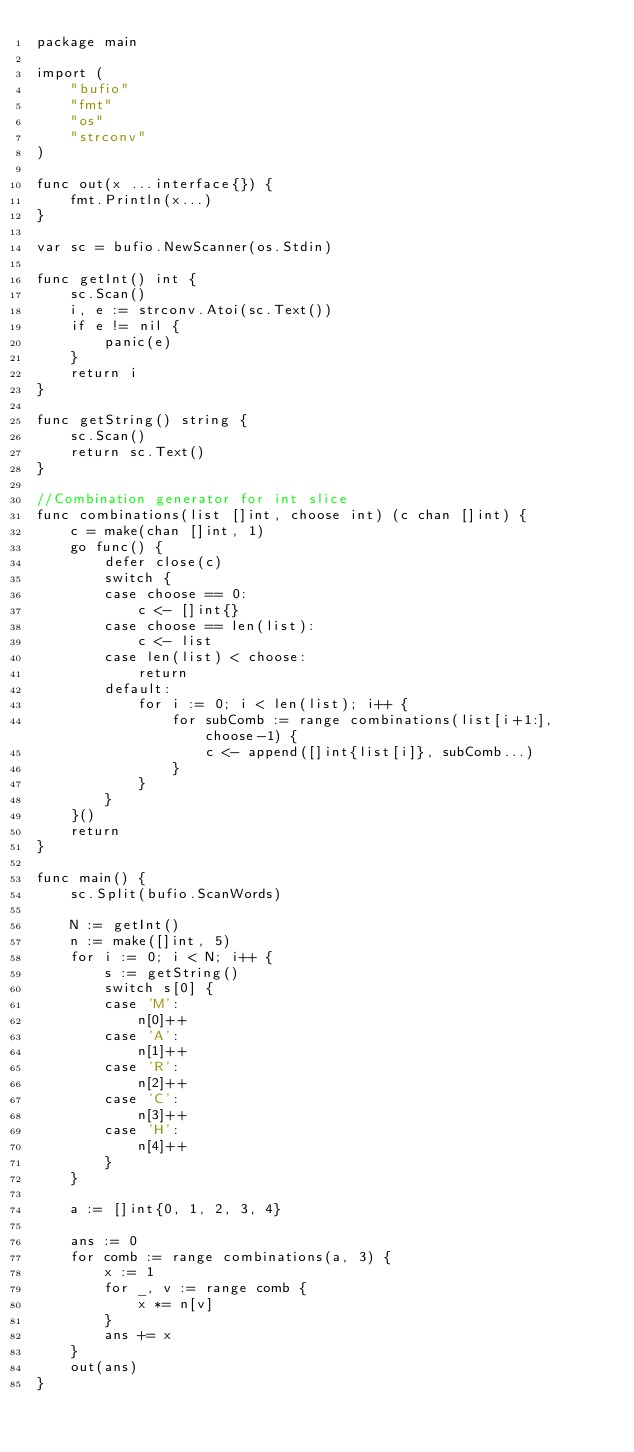<code> <loc_0><loc_0><loc_500><loc_500><_Go_>package main

import (
	"bufio"
	"fmt"
	"os"
	"strconv"
)

func out(x ...interface{}) {
	fmt.Println(x...)
}

var sc = bufio.NewScanner(os.Stdin)

func getInt() int {
	sc.Scan()
	i, e := strconv.Atoi(sc.Text())
	if e != nil {
		panic(e)
	}
	return i
}

func getString() string {
	sc.Scan()
	return sc.Text()
}

//Combination generator for int slice
func combinations(list []int, choose int) (c chan []int) {
	c = make(chan []int, 1)
	go func() {
		defer close(c)
		switch {
		case choose == 0:
			c <- []int{}
		case choose == len(list):
			c <- list
		case len(list) < choose:
			return
		default:
			for i := 0; i < len(list); i++ {
				for subComb := range combinations(list[i+1:], choose-1) {
					c <- append([]int{list[i]}, subComb...)
				}
			}
		}
	}()
	return
}

func main() {
	sc.Split(bufio.ScanWords)

	N := getInt()
	n := make([]int, 5)
	for i := 0; i < N; i++ {
		s := getString()
		switch s[0] {
		case 'M':
			n[0]++
		case 'A':
			n[1]++
		case 'R':
			n[2]++
		case 'C':
			n[3]++
		case 'H':
			n[4]++
		}
	}

	a := []int{0, 1, 2, 3, 4}

	ans := 0
	for comb := range combinations(a, 3) {
		x := 1
		for _, v := range comb {
			x *= n[v]
		}
		ans += x
	}
	out(ans)
}
</code> 